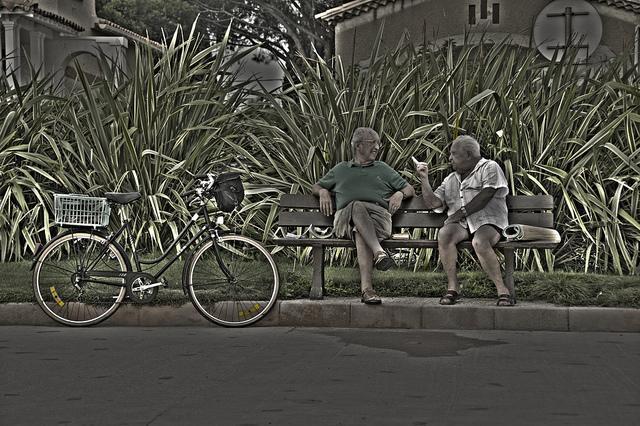How many women in this picture?
Give a very brief answer. 0. How many people can be seen?
Give a very brief answer. 2. How many bicycles are visible?
Give a very brief answer. 1. How many elephants are shown?
Give a very brief answer. 0. 